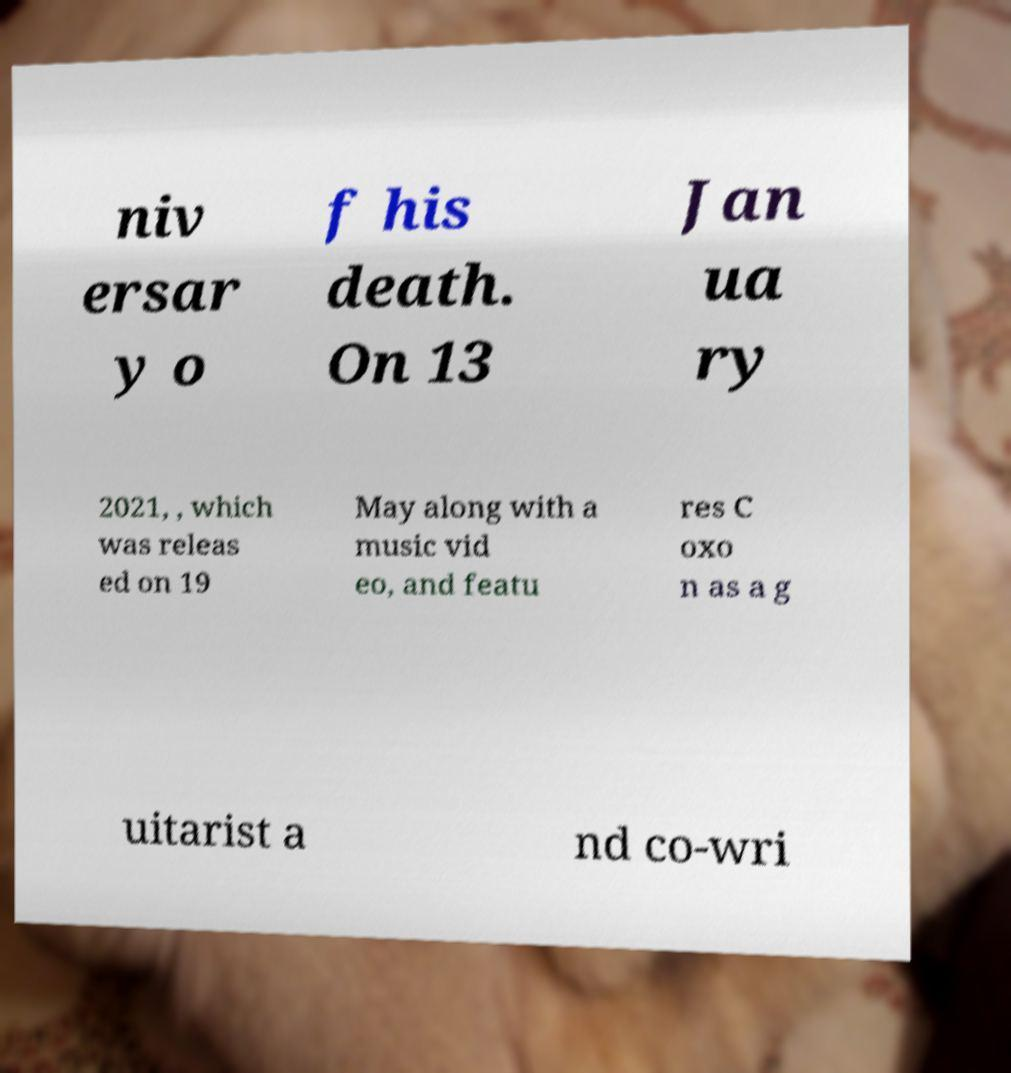Please identify and transcribe the text found in this image. niv ersar y o f his death. On 13 Jan ua ry 2021, , which was releas ed on 19 May along with a music vid eo, and featu res C oxo n as a g uitarist a nd co-wri 